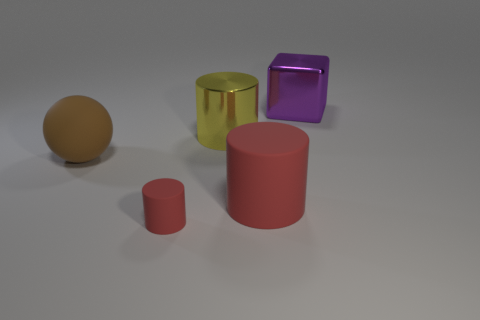There is a big yellow object; is it the same shape as the object left of the tiny red cylinder?
Your answer should be very brief. No. What number of metallic things are purple cubes or large blue cubes?
Keep it short and to the point. 1. Is there a big cylinder of the same color as the large ball?
Provide a succinct answer. No. Are there any small red matte cylinders?
Make the answer very short. Yes. Is the shape of the big red thing the same as the large yellow thing?
Provide a short and direct response. Yes. How many big objects are purple things or cylinders?
Ensure brevity in your answer.  3. What color is the cube?
Your answer should be compact. Purple. The big rubber object that is in front of the big thing that is to the left of the small red matte thing is what shape?
Your answer should be very brief. Cylinder. Are there any red objects made of the same material as the purple object?
Ensure brevity in your answer.  No. There is a cylinder behind the brown rubber ball; does it have the same size as the large block?
Provide a short and direct response. Yes. 